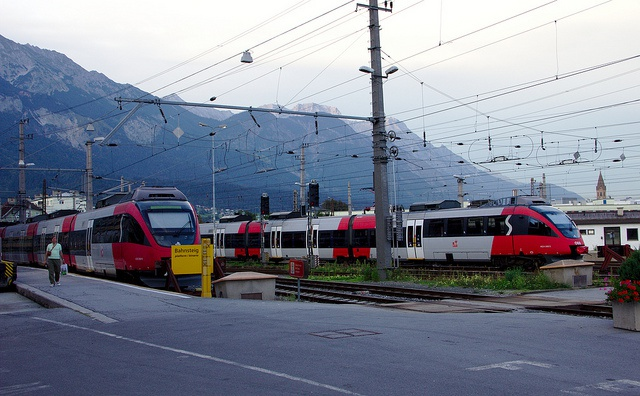Describe the objects in this image and their specific colors. I can see train in white, black, darkgray, brown, and gray tones, train in white, black, maroon, gray, and navy tones, potted plant in white, black, gray, maroon, and purple tones, people in white, black, gray, and maroon tones, and potted plant in white, black, darkgreen, maroon, and darkgray tones in this image. 